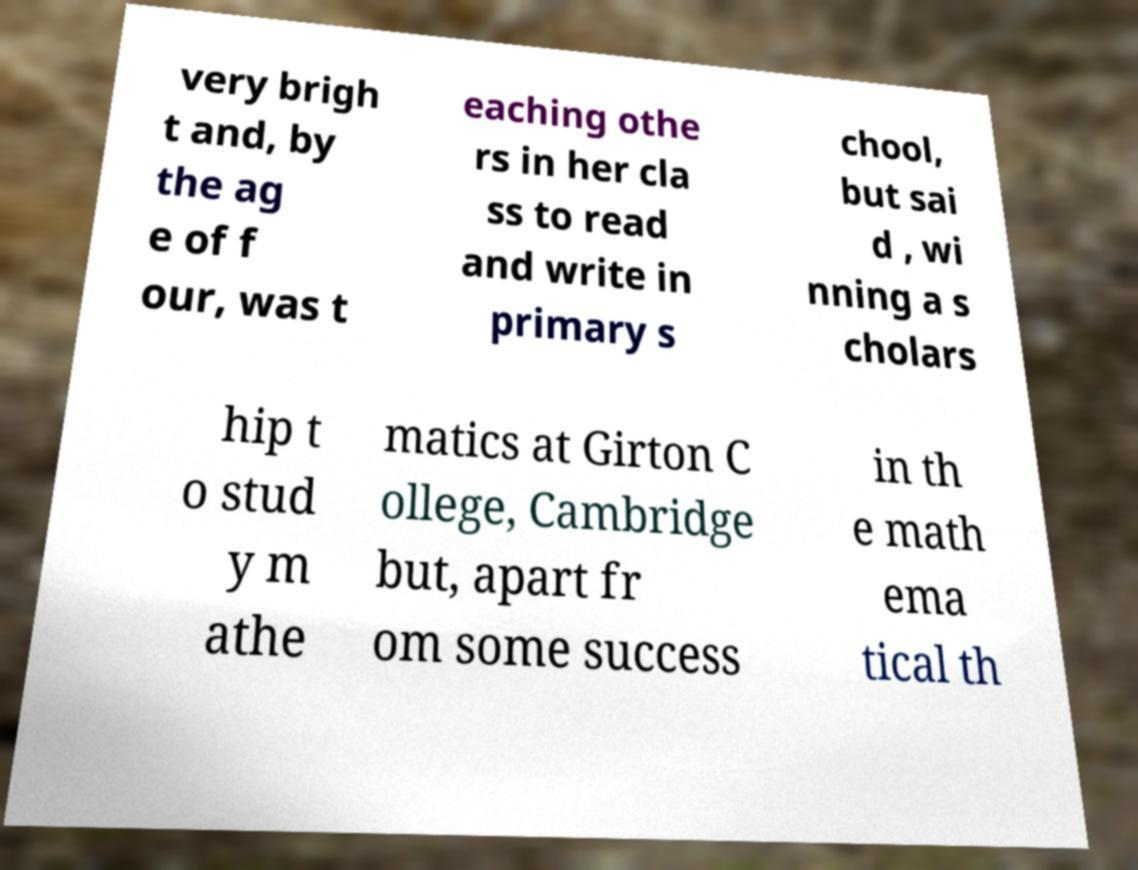Please identify and transcribe the text found in this image. very brigh t and, by the ag e of f our, was t eaching othe rs in her cla ss to read and write in primary s chool, but sai d , wi nning a s cholars hip t o stud y m athe matics at Girton C ollege, Cambridge but, apart fr om some success in th e math ema tical th 